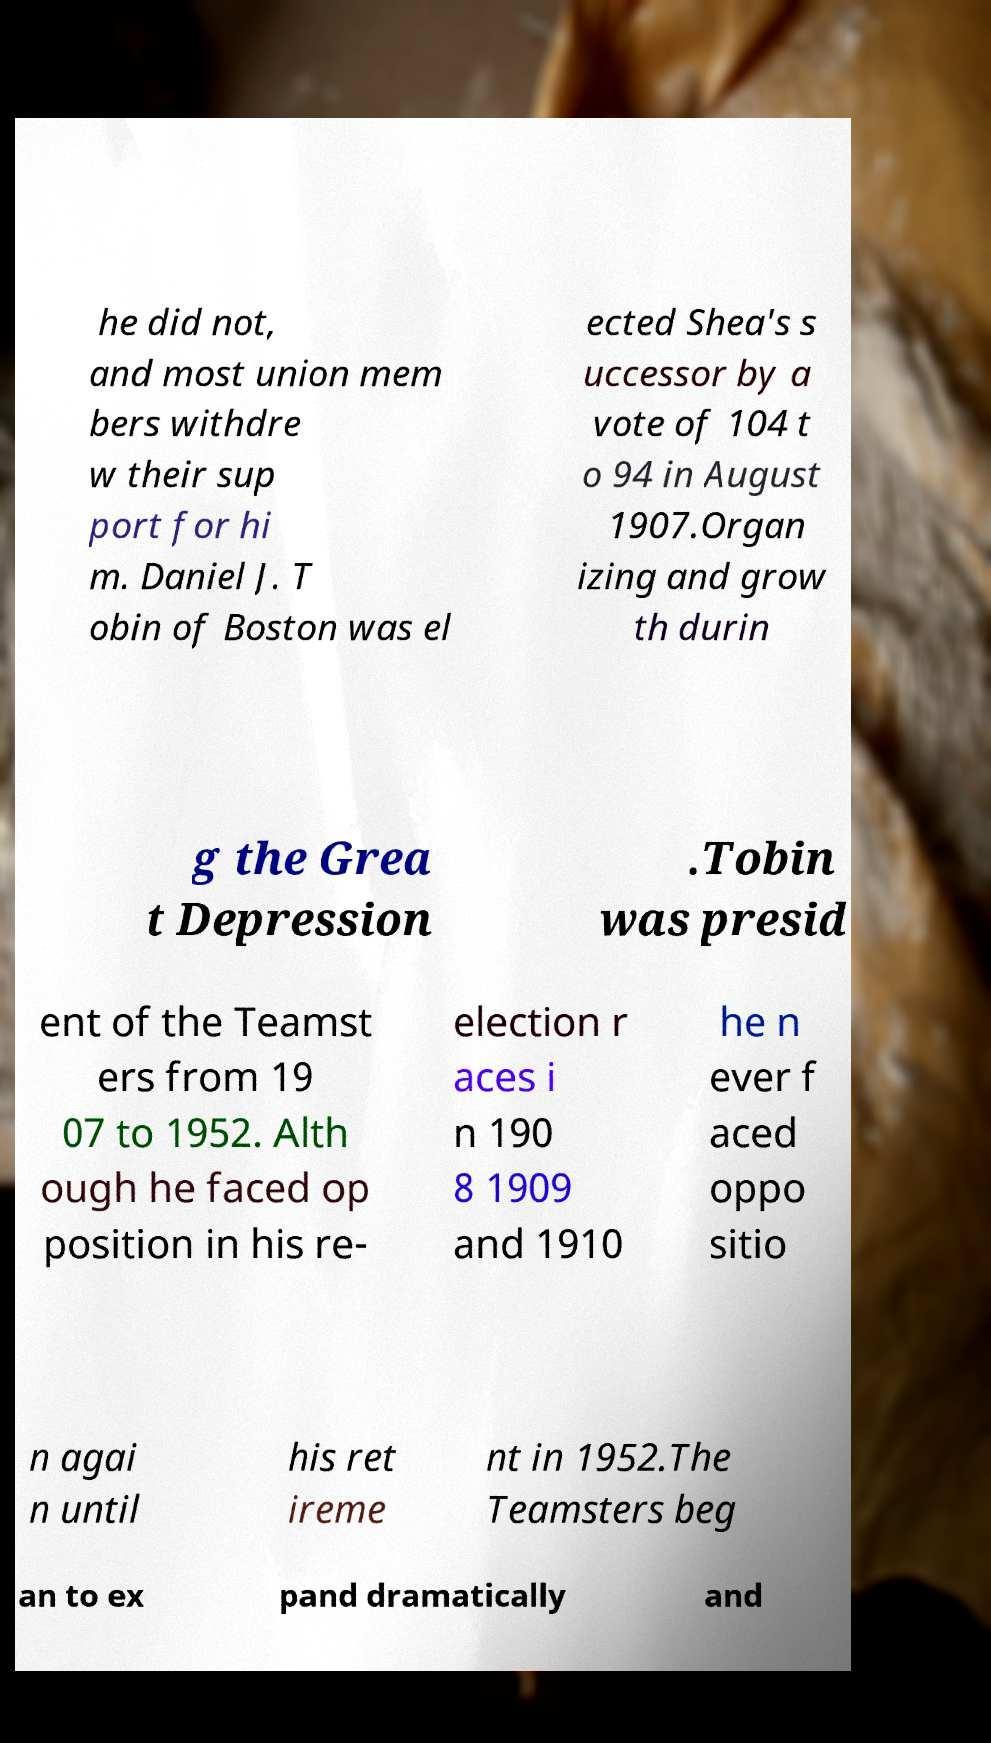Please identify and transcribe the text found in this image. he did not, and most union mem bers withdre w their sup port for hi m. Daniel J. T obin of Boston was el ected Shea's s uccessor by a vote of 104 t o 94 in August 1907.Organ izing and grow th durin g the Grea t Depression .Tobin was presid ent of the Teamst ers from 19 07 to 1952. Alth ough he faced op position in his re- election r aces i n 190 8 1909 and 1910 he n ever f aced oppo sitio n agai n until his ret ireme nt in 1952.The Teamsters beg an to ex pand dramatically and 